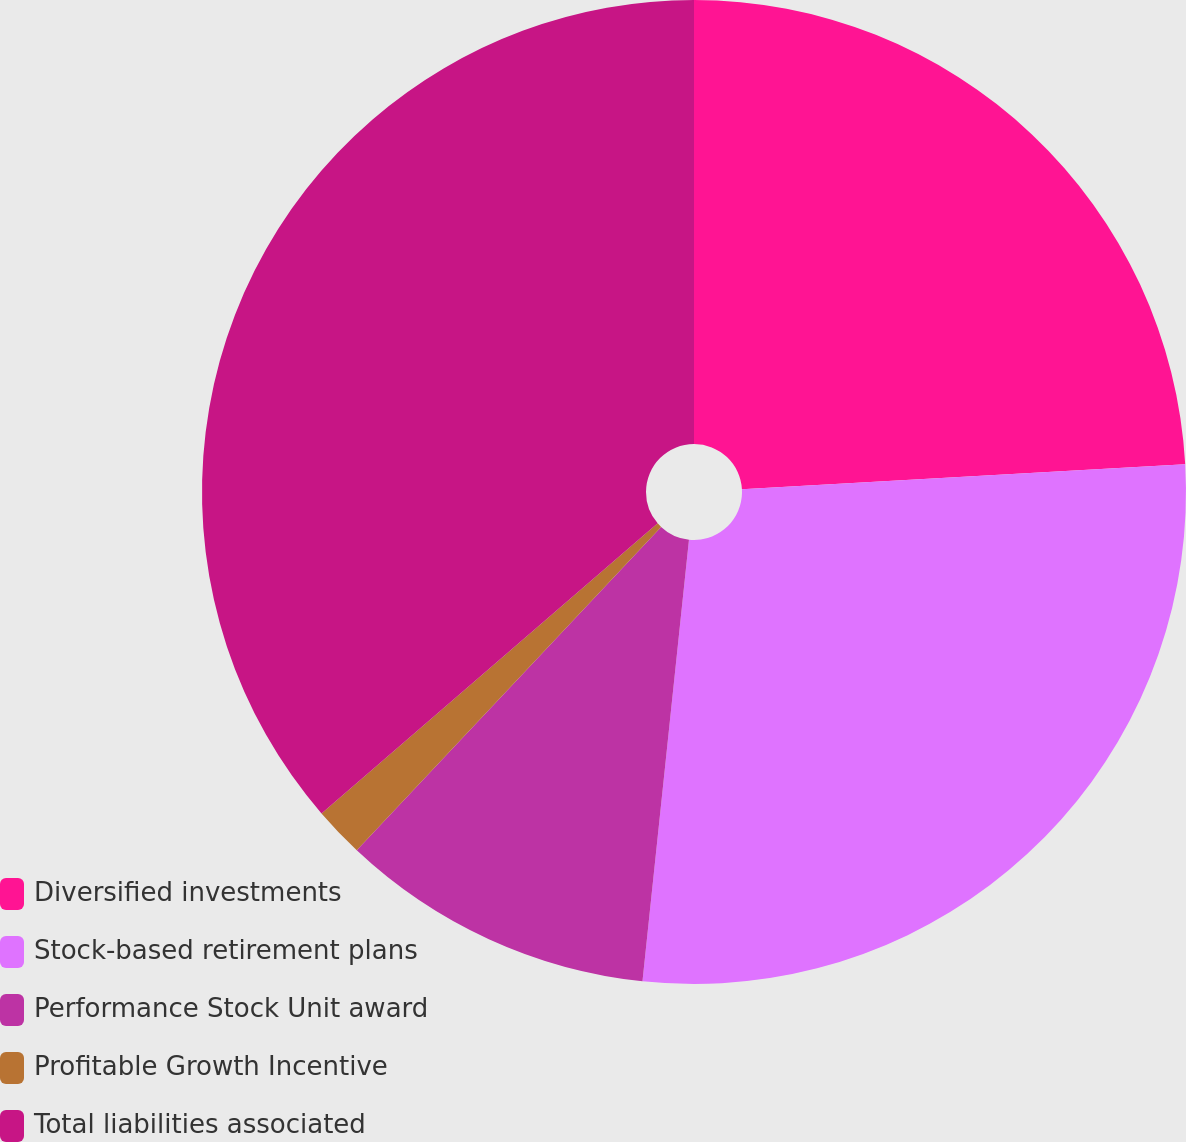<chart> <loc_0><loc_0><loc_500><loc_500><pie_chart><fcel>Diversified investments<fcel>Stock-based retirement plans<fcel>Performance Stock Unit award<fcel>Profitable Growth Incentive<fcel>Total liabilities associated<nl><fcel>24.1%<fcel>27.57%<fcel>10.35%<fcel>1.65%<fcel>36.33%<nl></chart> 